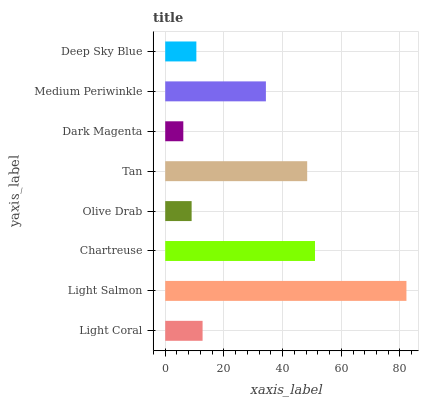Is Dark Magenta the minimum?
Answer yes or no. Yes. Is Light Salmon the maximum?
Answer yes or no. Yes. Is Chartreuse the minimum?
Answer yes or no. No. Is Chartreuse the maximum?
Answer yes or no. No. Is Light Salmon greater than Chartreuse?
Answer yes or no. Yes. Is Chartreuse less than Light Salmon?
Answer yes or no. Yes. Is Chartreuse greater than Light Salmon?
Answer yes or no. No. Is Light Salmon less than Chartreuse?
Answer yes or no. No. Is Medium Periwinkle the high median?
Answer yes or no. Yes. Is Light Coral the low median?
Answer yes or no. Yes. Is Light Salmon the high median?
Answer yes or no. No. Is Olive Drab the low median?
Answer yes or no. No. 